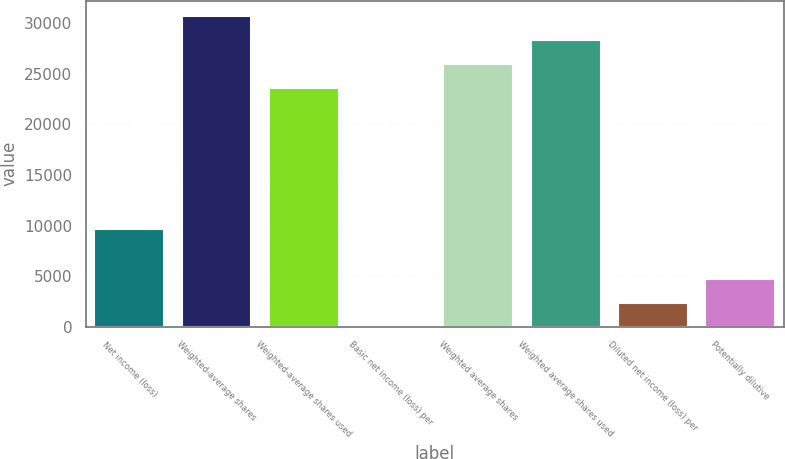Convert chart. <chart><loc_0><loc_0><loc_500><loc_500><bar_chart><fcel>Net income (loss)<fcel>Weighted-average shares<fcel>Weighted-average shares used<fcel>Basic net income (loss) per<fcel>Weighted average shares<fcel>Weighted average shares used<fcel>Diluted net income (loss) per<fcel>Potentially dilutive<nl><fcel>9623<fcel>30714.9<fcel>23626<fcel>0.41<fcel>25989<fcel>28351.9<fcel>2363.37<fcel>4726.33<nl></chart> 